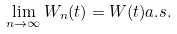<formula> <loc_0><loc_0><loc_500><loc_500>\lim _ { n \rightarrow \infty } W _ { n } ( t ) = W ( t ) a . s .</formula> 